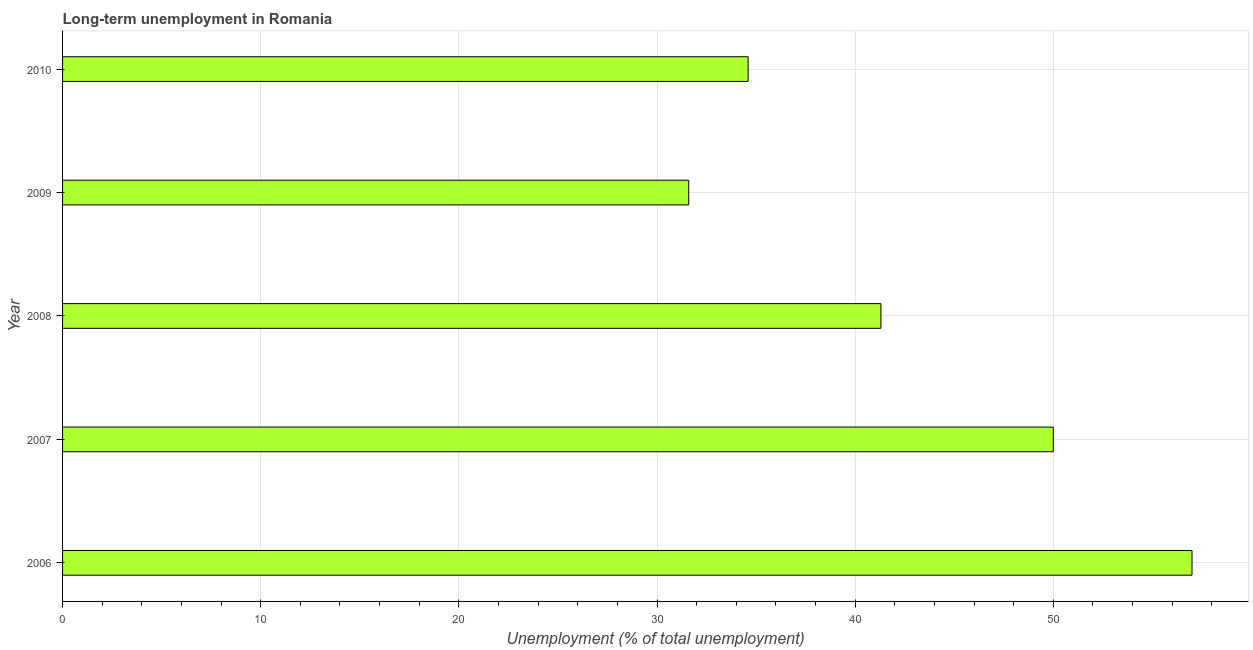Does the graph contain any zero values?
Make the answer very short. No. Does the graph contain grids?
Keep it short and to the point. Yes. What is the title of the graph?
Offer a very short reply. Long-term unemployment in Romania. What is the label or title of the X-axis?
Offer a terse response. Unemployment (% of total unemployment). What is the long-term unemployment in 2009?
Provide a short and direct response. 31.6. Across all years, what is the minimum long-term unemployment?
Offer a very short reply. 31.6. In which year was the long-term unemployment maximum?
Keep it short and to the point. 2006. In which year was the long-term unemployment minimum?
Your response must be concise. 2009. What is the sum of the long-term unemployment?
Your response must be concise. 214.5. What is the difference between the long-term unemployment in 2006 and 2008?
Keep it short and to the point. 15.7. What is the average long-term unemployment per year?
Your response must be concise. 42.9. What is the median long-term unemployment?
Make the answer very short. 41.3. Do a majority of the years between 2009 and 2010 (inclusive) have long-term unemployment greater than 22 %?
Keep it short and to the point. Yes. What is the ratio of the long-term unemployment in 2006 to that in 2007?
Offer a very short reply. 1.14. Is the difference between the long-term unemployment in 2008 and 2009 greater than the difference between any two years?
Give a very brief answer. No. Is the sum of the long-term unemployment in 2009 and 2010 greater than the maximum long-term unemployment across all years?
Provide a short and direct response. Yes. What is the difference between the highest and the lowest long-term unemployment?
Ensure brevity in your answer.  25.4. What is the Unemployment (% of total unemployment) in 2006?
Your response must be concise. 57. What is the Unemployment (% of total unemployment) of 2007?
Provide a short and direct response. 50. What is the Unemployment (% of total unemployment) in 2008?
Give a very brief answer. 41.3. What is the Unemployment (% of total unemployment) of 2009?
Keep it short and to the point. 31.6. What is the Unemployment (% of total unemployment) in 2010?
Your answer should be very brief. 34.6. What is the difference between the Unemployment (% of total unemployment) in 2006 and 2008?
Provide a succinct answer. 15.7. What is the difference between the Unemployment (% of total unemployment) in 2006 and 2009?
Offer a terse response. 25.4. What is the difference between the Unemployment (% of total unemployment) in 2006 and 2010?
Your response must be concise. 22.4. What is the difference between the Unemployment (% of total unemployment) in 2007 and 2008?
Provide a succinct answer. 8.7. What is the difference between the Unemployment (% of total unemployment) in 2007 and 2009?
Offer a very short reply. 18.4. What is the difference between the Unemployment (% of total unemployment) in 2008 and 2010?
Offer a terse response. 6.7. What is the ratio of the Unemployment (% of total unemployment) in 2006 to that in 2007?
Give a very brief answer. 1.14. What is the ratio of the Unemployment (% of total unemployment) in 2006 to that in 2008?
Your answer should be very brief. 1.38. What is the ratio of the Unemployment (% of total unemployment) in 2006 to that in 2009?
Ensure brevity in your answer.  1.8. What is the ratio of the Unemployment (% of total unemployment) in 2006 to that in 2010?
Ensure brevity in your answer.  1.65. What is the ratio of the Unemployment (% of total unemployment) in 2007 to that in 2008?
Your answer should be compact. 1.21. What is the ratio of the Unemployment (% of total unemployment) in 2007 to that in 2009?
Your answer should be very brief. 1.58. What is the ratio of the Unemployment (% of total unemployment) in 2007 to that in 2010?
Provide a short and direct response. 1.45. What is the ratio of the Unemployment (% of total unemployment) in 2008 to that in 2009?
Give a very brief answer. 1.31. What is the ratio of the Unemployment (% of total unemployment) in 2008 to that in 2010?
Your response must be concise. 1.19. 